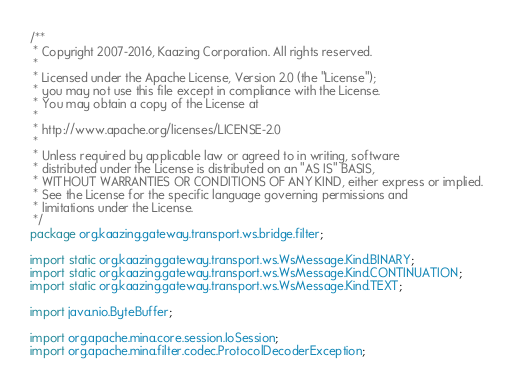Convert code to text. <code><loc_0><loc_0><loc_500><loc_500><_Java_>/**
 * Copyright 2007-2016, Kaazing Corporation. All rights reserved.
 *
 * Licensed under the Apache License, Version 2.0 (the "License");
 * you may not use this file except in compliance with the License.
 * You may obtain a copy of the License at
 *
 * http://www.apache.org/licenses/LICENSE-2.0
 *
 * Unless required by applicable law or agreed to in writing, software
 * distributed under the License is distributed on an "AS IS" BASIS,
 * WITHOUT WARRANTIES OR CONDITIONS OF ANY KIND, either express or implied.
 * See the License for the specific language governing permissions and
 * limitations under the License.
 */
package org.kaazing.gateway.transport.ws.bridge.filter;

import static org.kaazing.gateway.transport.ws.WsMessage.Kind.BINARY;
import static org.kaazing.gateway.transport.ws.WsMessage.Kind.CONTINUATION;
import static org.kaazing.gateway.transport.ws.WsMessage.Kind.TEXT;

import java.nio.ByteBuffer;

import org.apache.mina.core.session.IoSession;
import org.apache.mina.filter.codec.ProtocolDecoderException;</code> 